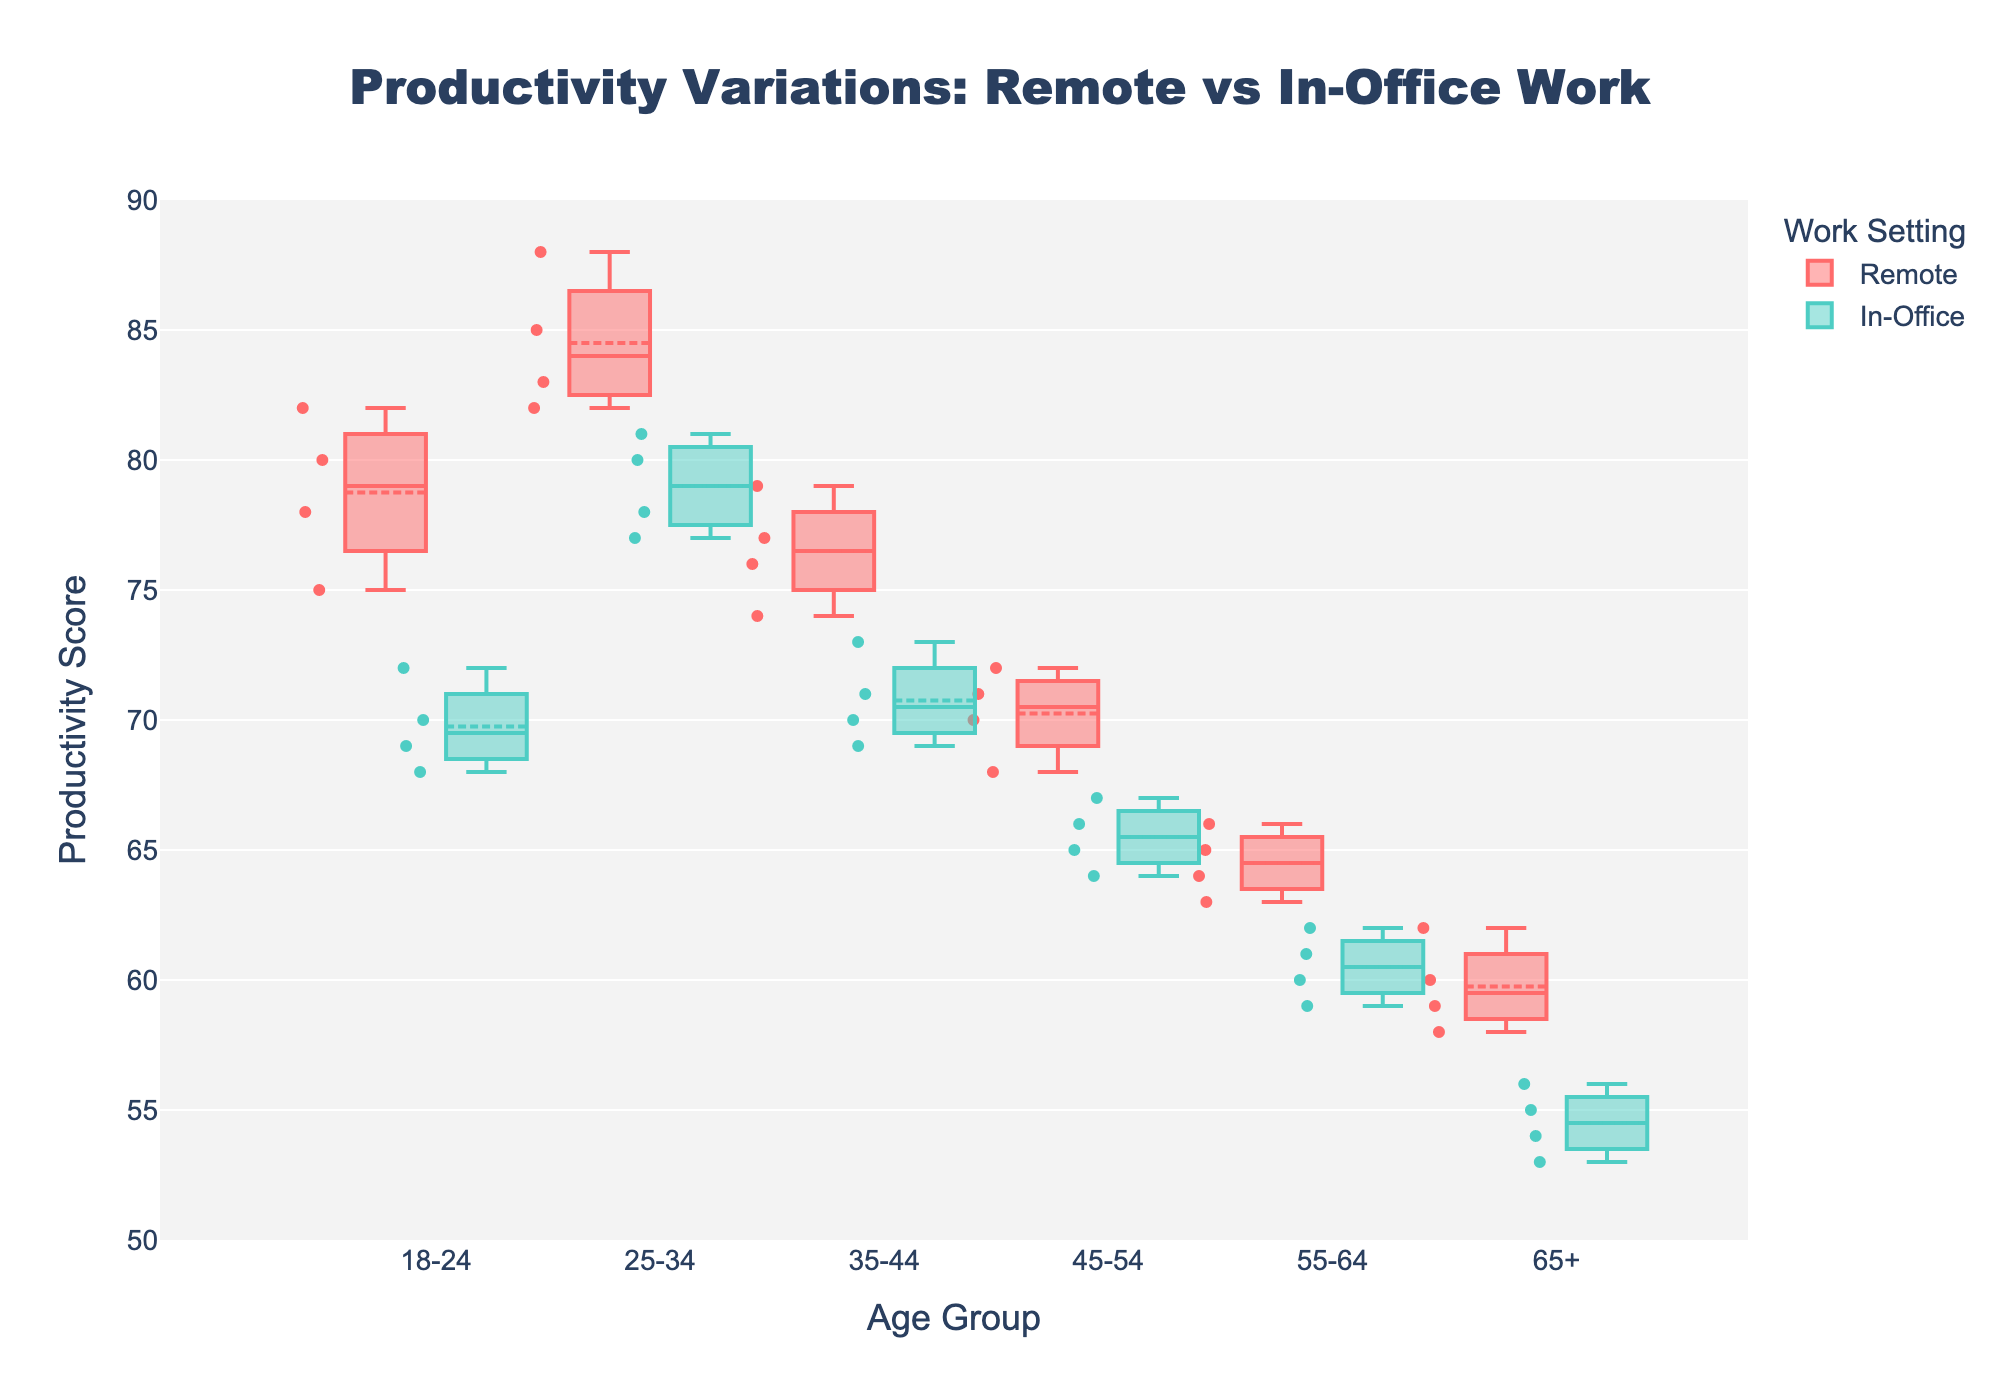What is the range of Productivity Scores for the 18-24 age group in the Remote work setting? Look at the plot specific to the 18-24 age group and find the minimum and maximum values within the Remote work setting's box plot.
Answer: 75-82 Which age group shows the highest median productivity score in the Remote work setting? Check each box plot in the Remote work setting. The median is represented by the line inside the box. Identify the age group with the highest position of this line.
Answer: 25-34 How does the median productivity for the 45-54 age group compare between Remote and In-Office settings? Locate the 45-54 age group for both settings and compare the medians as represented by the lines inside the boxes.
Answer: Higher in Remote What is the interquartile range (IQR) of the productivity scores for the 35-44 age group in the Remote setting? The IQR is the difference between the upper quartile (Q3) and lower quartile (Q1). Find these values from the box plot and subtract Q1 from Q3.
Answer: 3 Which age group has the lowest productivity scores in both work settings? Identify the lowest points or the bottom whiskers of the box plots for both settings and compare these values across age groups.
Answer: 65+ How do the mean productivity scores for the 25-34 age group compare between Remote and In-Office settings? The mean is indicated by a mean symbol or dot. Find these symbols in the box plots for the 25-34 age group and compare their positions.
Answer: Higher in Remote For the 55-64 age group, is the variability in productivity higher in Remote or In-Office settings? Variability can be assessed by the length of the box and whiskers. Compare these lengths for the 55-64 age group in both settings.
Answer: Remote How does the median productivity score of the Remote work setting change across different age groups? Track the position of the median line across the Remote work setting's box plots for each age group and observe how it moves.
Answer: Decreases with age What is the difference in the median productivity scores between the 25-34 and 45-54 age groups in the Remote setting? Compare the median lines (inside the boxes) of the 25-34 and 45-54 age groups in the Remote setting and calculate the difference.
Answer: 12 units 